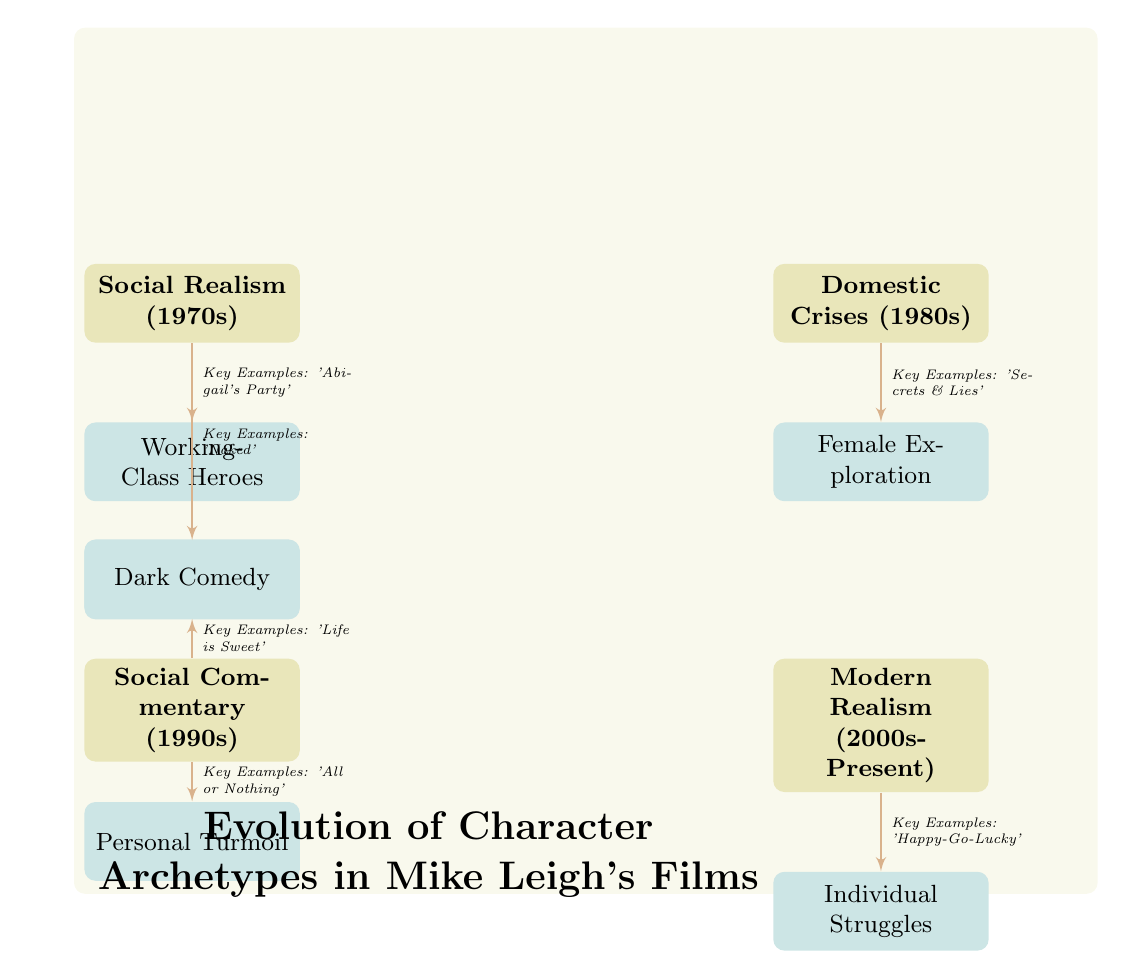What are the four periods depicted in the diagram? The diagram outlines four distinct periods: Social Realism (1970s), Domestic Crises (1980s), Social Commentary (1990s), and Modern Realism (2000s-Present).
Answer: Social Realism, Domestic Crises, Social Commentary, Modern Realism Which character archetype exemplifies the 1980s? The character archetype associated with the 1980s in the diagram is Female Exploration, which is linked to the Domestic Crises period.
Answer: Female Exploration How many character archetypes are represented in the diagram? The diagram shows a total of six character archetypes that are connected to different periods of Mike Leigh's films.
Answer: Six What key example is associated with the 'Working-Class Heroes' archetype? The diagram indicates that 'Abigail's Party' is a key example tied to the 'Working-Class Heroes' archetype representing the Social Realism period.
Answer: Abigail's Party During which period is 'All or Nothing' used as a key example? The diagram highlights 'All or Nothing' as a key example during the Social Commentary period of the 1990s.
Answer: Social Commentary What relationship exists between the 'Dark Comedy' archetype and its period? The 'Dark Comedy' archetype is portrayed as stemming from the Social Commentary period, indicating a focus on this type of storytelling in that time frame.
Answer: Social Commentary List the archetype connected to the Modern Realism period. The 'Individual Struggles' archetype is connected to the Modern Realism period in the diagram, showcasing the focus on personal challenges in Mike Leigh's recent films.
Answer: Individual Struggles How does 'Naked' relate to the character archetypes? 'Naked' is identified in the diagram as a key example of the 'Ambivalent Protagonists' archetype linked to the Social Realism period, indicating its thematic relevance.
Answer: Ambivalent Protagonists 